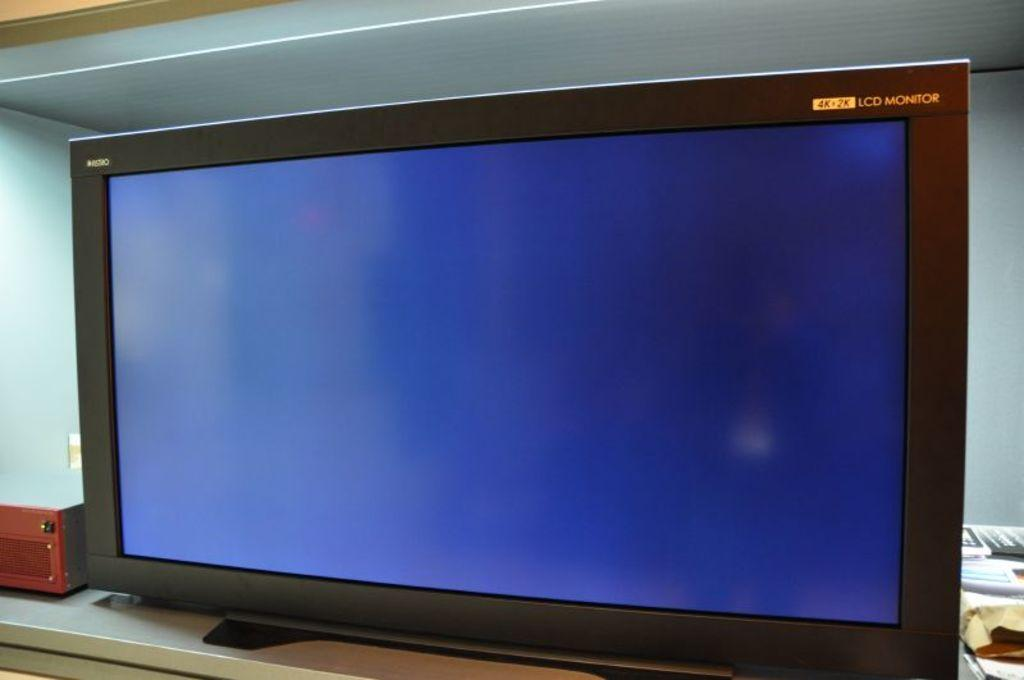<image>
Share a concise interpretation of the image provided. A 4k + 2K LCD monitor has a blue screen, with nothing else on it. 